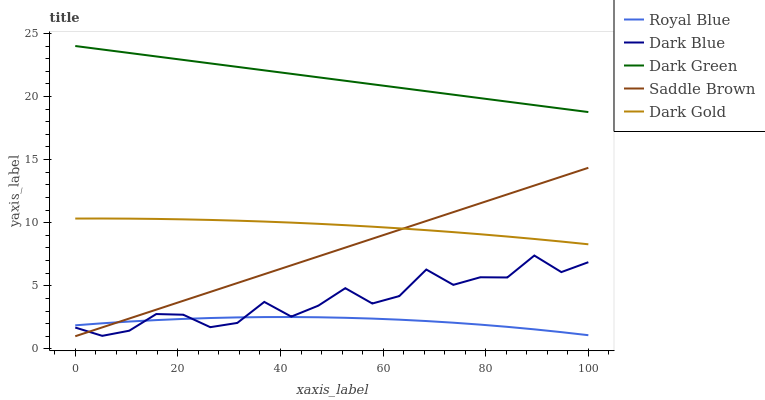Does Royal Blue have the minimum area under the curve?
Answer yes or no. Yes. Does Dark Green have the maximum area under the curve?
Answer yes or no. Yes. Does Saddle Brown have the minimum area under the curve?
Answer yes or no. No. Does Saddle Brown have the maximum area under the curve?
Answer yes or no. No. Is Saddle Brown the smoothest?
Answer yes or no. Yes. Is Dark Blue the roughest?
Answer yes or no. Yes. Is Dark Green the smoothest?
Answer yes or no. No. Is Dark Green the roughest?
Answer yes or no. No. Does Saddle Brown have the lowest value?
Answer yes or no. Yes. Does Dark Green have the lowest value?
Answer yes or no. No. Does Dark Green have the highest value?
Answer yes or no. Yes. Does Saddle Brown have the highest value?
Answer yes or no. No. Is Royal Blue less than Dark Green?
Answer yes or no. Yes. Is Dark Green greater than Dark Blue?
Answer yes or no. Yes. Does Saddle Brown intersect Royal Blue?
Answer yes or no. Yes. Is Saddle Brown less than Royal Blue?
Answer yes or no. No. Is Saddle Brown greater than Royal Blue?
Answer yes or no. No. Does Royal Blue intersect Dark Green?
Answer yes or no. No. 